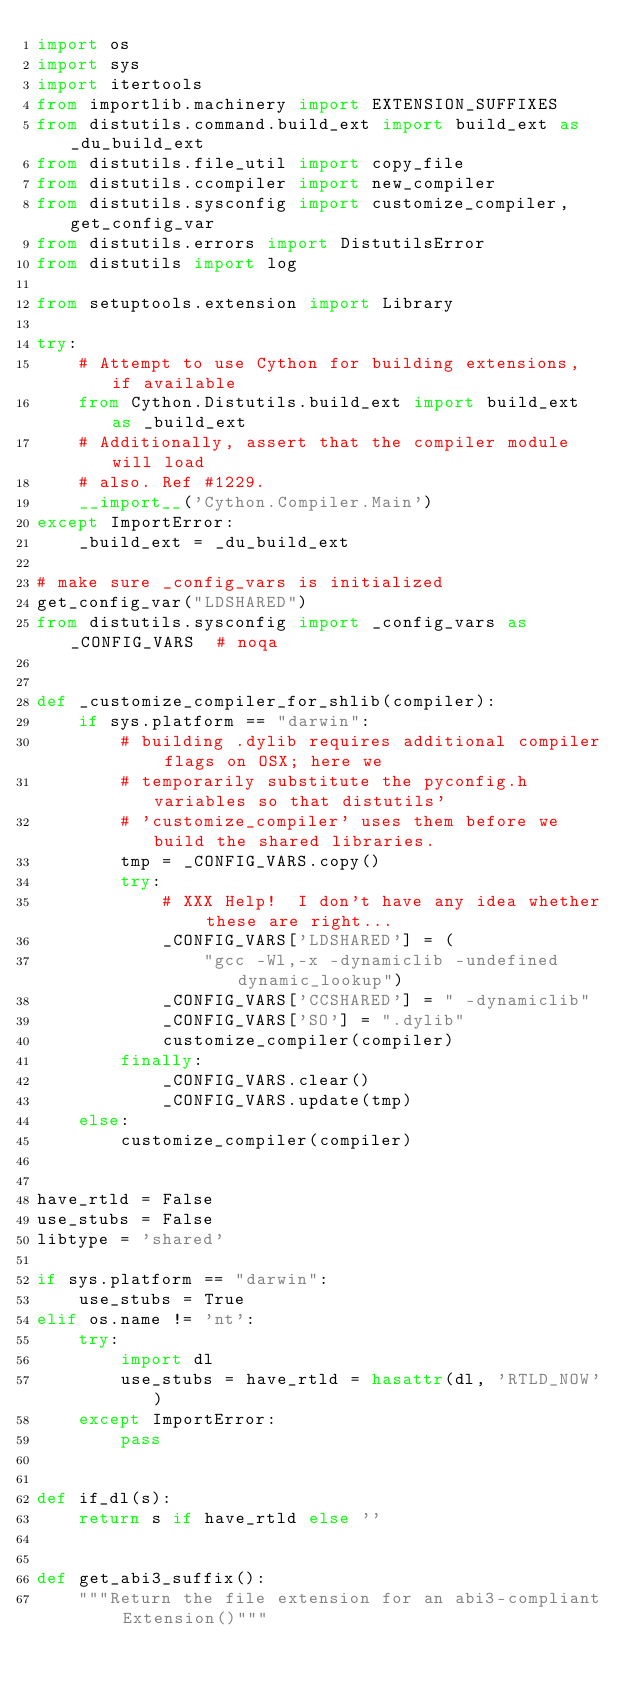Convert code to text. <code><loc_0><loc_0><loc_500><loc_500><_Python_>import os
import sys
import itertools
from importlib.machinery import EXTENSION_SUFFIXES
from distutils.command.build_ext import build_ext as _du_build_ext
from distutils.file_util import copy_file
from distutils.ccompiler import new_compiler
from distutils.sysconfig import customize_compiler, get_config_var
from distutils.errors import DistutilsError
from distutils import log

from setuptools.extension import Library

try:
    # Attempt to use Cython for building extensions, if available
    from Cython.Distutils.build_ext import build_ext as _build_ext
    # Additionally, assert that the compiler module will load
    # also. Ref #1229.
    __import__('Cython.Compiler.Main')
except ImportError:
    _build_ext = _du_build_ext

# make sure _config_vars is initialized
get_config_var("LDSHARED")
from distutils.sysconfig import _config_vars as _CONFIG_VARS  # noqa


def _customize_compiler_for_shlib(compiler):
    if sys.platform == "darwin":
        # building .dylib requires additional compiler flags on OSX; here we
        # temporarily substitute the pyconfig.h variables so that distutils'
        # 'customize_compiler' uses them before we build the shared libraries.
        tmp = _CONFIG_VARS.copy()
        try:
            # XXX Help!  I don't have any idea whether these are right...
            _CONFIG_VARS['LDSHARED'] = (
                "gcc -Wl,-x -dynamiclib -undefined dynamic_lookup")
            _CONFIG_VARS['CCSHARED'] = " -dynamiclib"
            _CONFIG_VARS['SO'] = ".dylib"
            customize_compiler(compiler)
        finally:
            _CONFIG_VARS.clear()
            _CONFIG_VARS.update(tmp)
    else:
        customize_compiler(compiler)


have_rtld = False
use_stubs = False
libtype = 'shared'

if sys.platform == "darwin":
    use_stubs = True
elif os.name != 'nt':
    try:
        import dl
        use_stubs = have_rtld = hasattr(dl, 'RTLD_NOW')
    except ImportError:
        pass


def if_dl(s):
    return s if have_rtld else ''


def get_abi3_suffix():
    """Return the file extension for an abi3-compliant Extension()"""</code> 